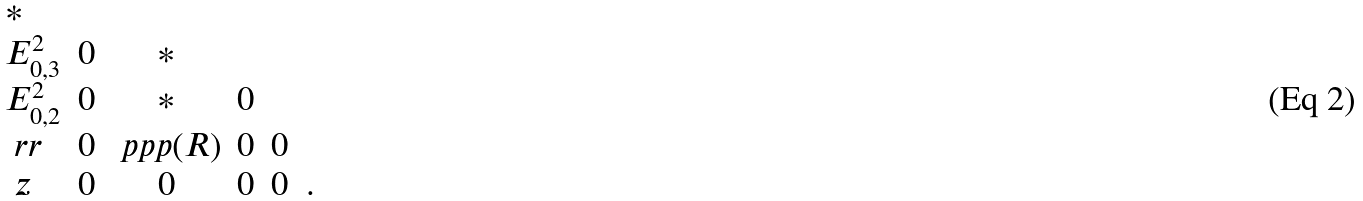<formula> <loc_0><loc_0><loc_500><loc_500>\begin{array} { l c c c c c } \ast & & & & & \\ E _ { 0 , 3 } ^ { 2 } & 0 & \ast & & & \\ E _ { 0 , 2 } ^ { 2 } & 0 & \ast & 0 & & \\ \ r r & 0 & \ p p p ( R ) & 0 & 0 & \\ \ z & 0 & 0 & 0 & 0 & . \end{array}</formula> 